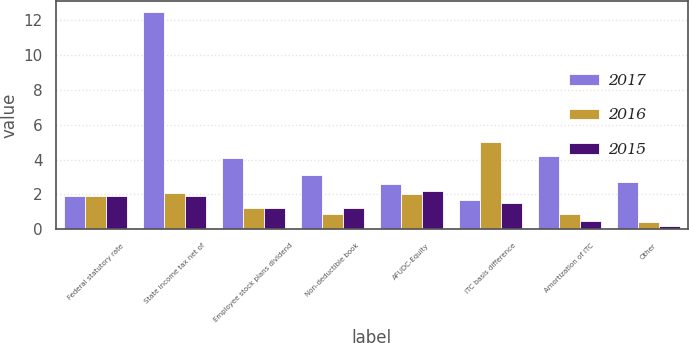Convert chart. <chart><loc_0><loc_0><loc_500><loc_500><stacked_bar_chart><ecel><fcel>Federal statutory rate<fcel>State income tax net of<fcel>Employee stock plans dividend<fcel>Non-deductible book<fcel>AFUDC-Equity<fcel>ITC basis difference<fcel>Amortization of ITC<fcel>Other<nl><fcel>2017<fcel>1.9<fcel>12.5<fcel>4.1<fcel>3.1<fcel>2.6<fcel>1.7<fcel>4.2<fcel>2.7<nl><fcel>2016<fcel>1.9<fcel>2.1<fcel>1.2<fcel>0.9<fcel>2<fcel>5<fcel>0.9<fcel>0.4<nl><fcel>2015<fcel>1.9<fcel>1.9<fcel>1.2<fcel>1.2<fcel>2.2<fcel>1.5<fcel>0.5<fcel>0.2<nl></chart> 